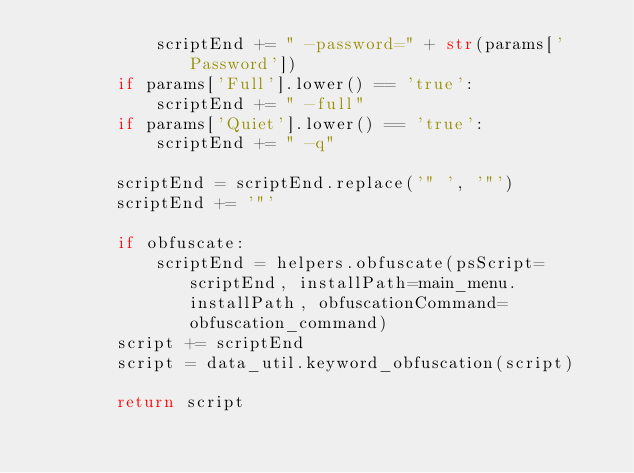<code> <loc_0><loc_0><loc_500><loc_500><_Python_>            scriptEnd += " -password=" + str(params['Password'])
        if params['Full'].lower() == 'true':
            scriptEnd += " -full"
        if params['Quiet'].lower() == 'true':
            scriptEnd += " -q"

        scriptEnd = scriptEnd.replace('" ', '"')
        scriptEnd += '"'

        if obfuscate:
            scriptEnd = helpers.obfuscate(psScript=scriptEnd, installPath=main_menu.installPath, obfuscationCommand=obfuscation_command)
        script += scriptEnd
        script = data_util.keyword_obfuscation(script)

        return script

</code> 